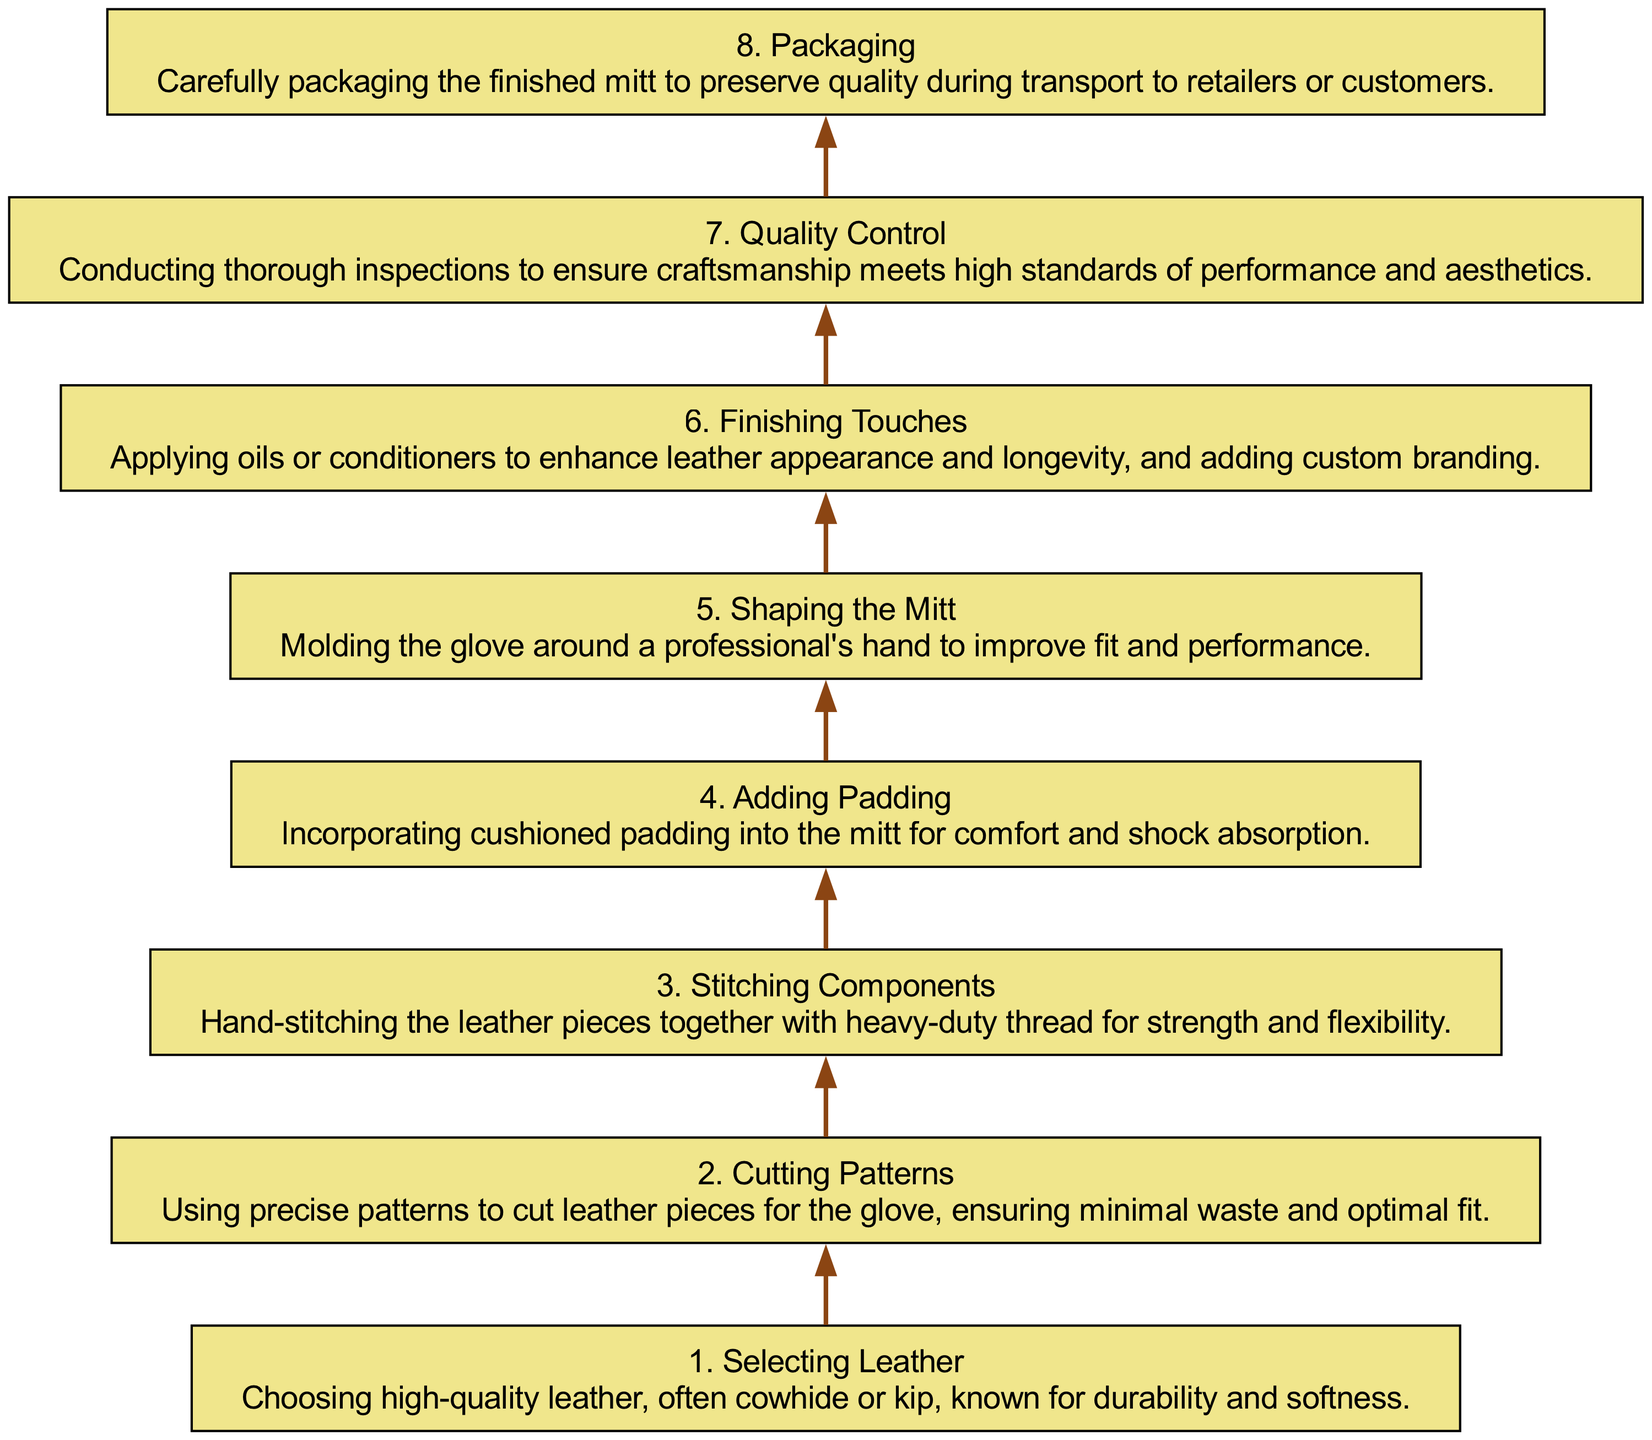What is the first step in the production process? The diagram clearly shows that the first step is "Selecting Leather." This is at the bottom and serves as the starting point of the flow.
Answer: Selecting Leather How many steps are there in total? By counting the number of nodes in the diagram, there are eight distinct steps listed for the crafting process of a baseball mitt.
Answer: 8 What step involves hand-stitching? The diagram specifies that "Stitching Components" is the step where hand-stitching takes place. It's indicated clearly as one of the middle stages of production.
Answer: Stitching Components What is performed after "Adding Padding"? The diagram shows that "Shaping the Mitt" follows "Adding Padding." This indicates that the mitt is then molded for better fit after padding is incorporated.
Answer: Shaping the Mitt Which process is the final step before packaging? The last step before "Packaging" is "Quality Control," where thorough inspections to ensure craftsmanship are conducted. This step is a crucial part of the process just before the mitt is packaged.
Answer: Quality Control What material is predominantly used in the glove production? The diagram indicates that high-quality leather, often cowhide or kip, is used in the "Selecting Leather" step, marking it as the primary material for the mitt.
Answer: Leather What step focuses on the mitt's appearance and branding? The "Finishing Touches" step emphasizes applying oils or conditioners for appearance and adding custom branding, which enhances both aesthetics and branding for the product.
Answer: Finishing Touches How does the mitt's shape improve its performance? The step "Shaping the Mitt" involves molding the glove around a professional's hand, which directly relates to improving the mitt's fit and performance. This shaping is crucial for usability during play.
Answer: Molding around a professional's hand 